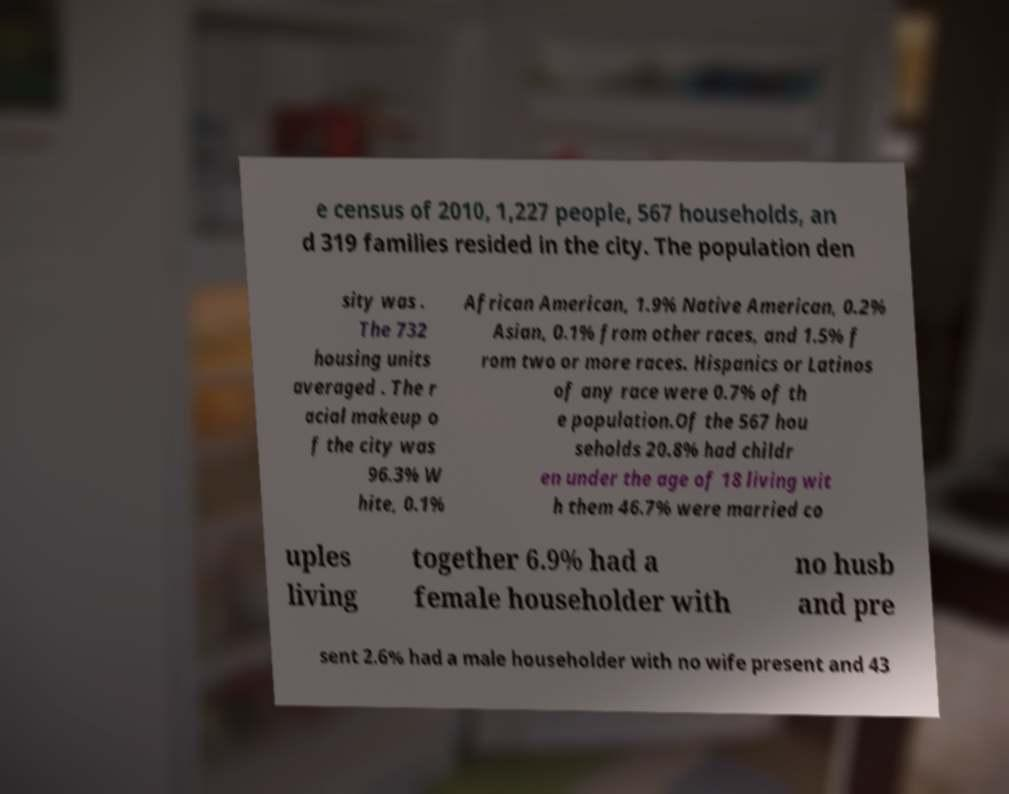Can you accurately transcribe the text from the provided image for me? e census of 2010, 1,227 people, 567 households, an d 319 families resided in the city. The population den sity was . The 732 housing units averaged . The r acial makeup o f the city was 96.3% W hite, 0.1% African American, 1.9% Native American, 0.2% Asian, 0.1% from other races, and 1.5% f rom two or more races. Hispanics or Latinos of any race were 0.7% of th e population.Of the 567 hou seholds 20.8% had childr en under the age of 18 living wit h them 46.7% were married co uples living together 6.9% had a female householder with no husb and pre sent 2.6% had a male householder with no wife present and 43 